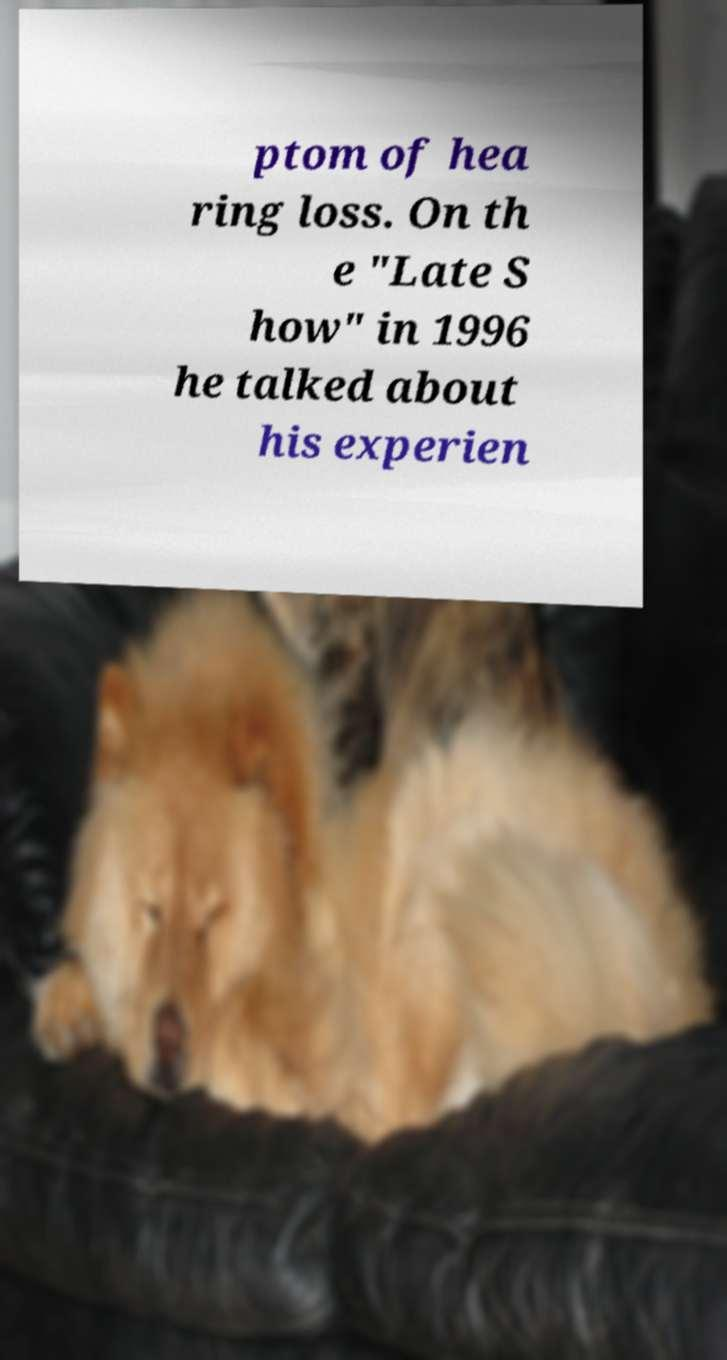Can you accurately transcribe the text from the provided image for me? ptom of hea ring loss. On th e "Late S how" in 1996 he talked about his experien 